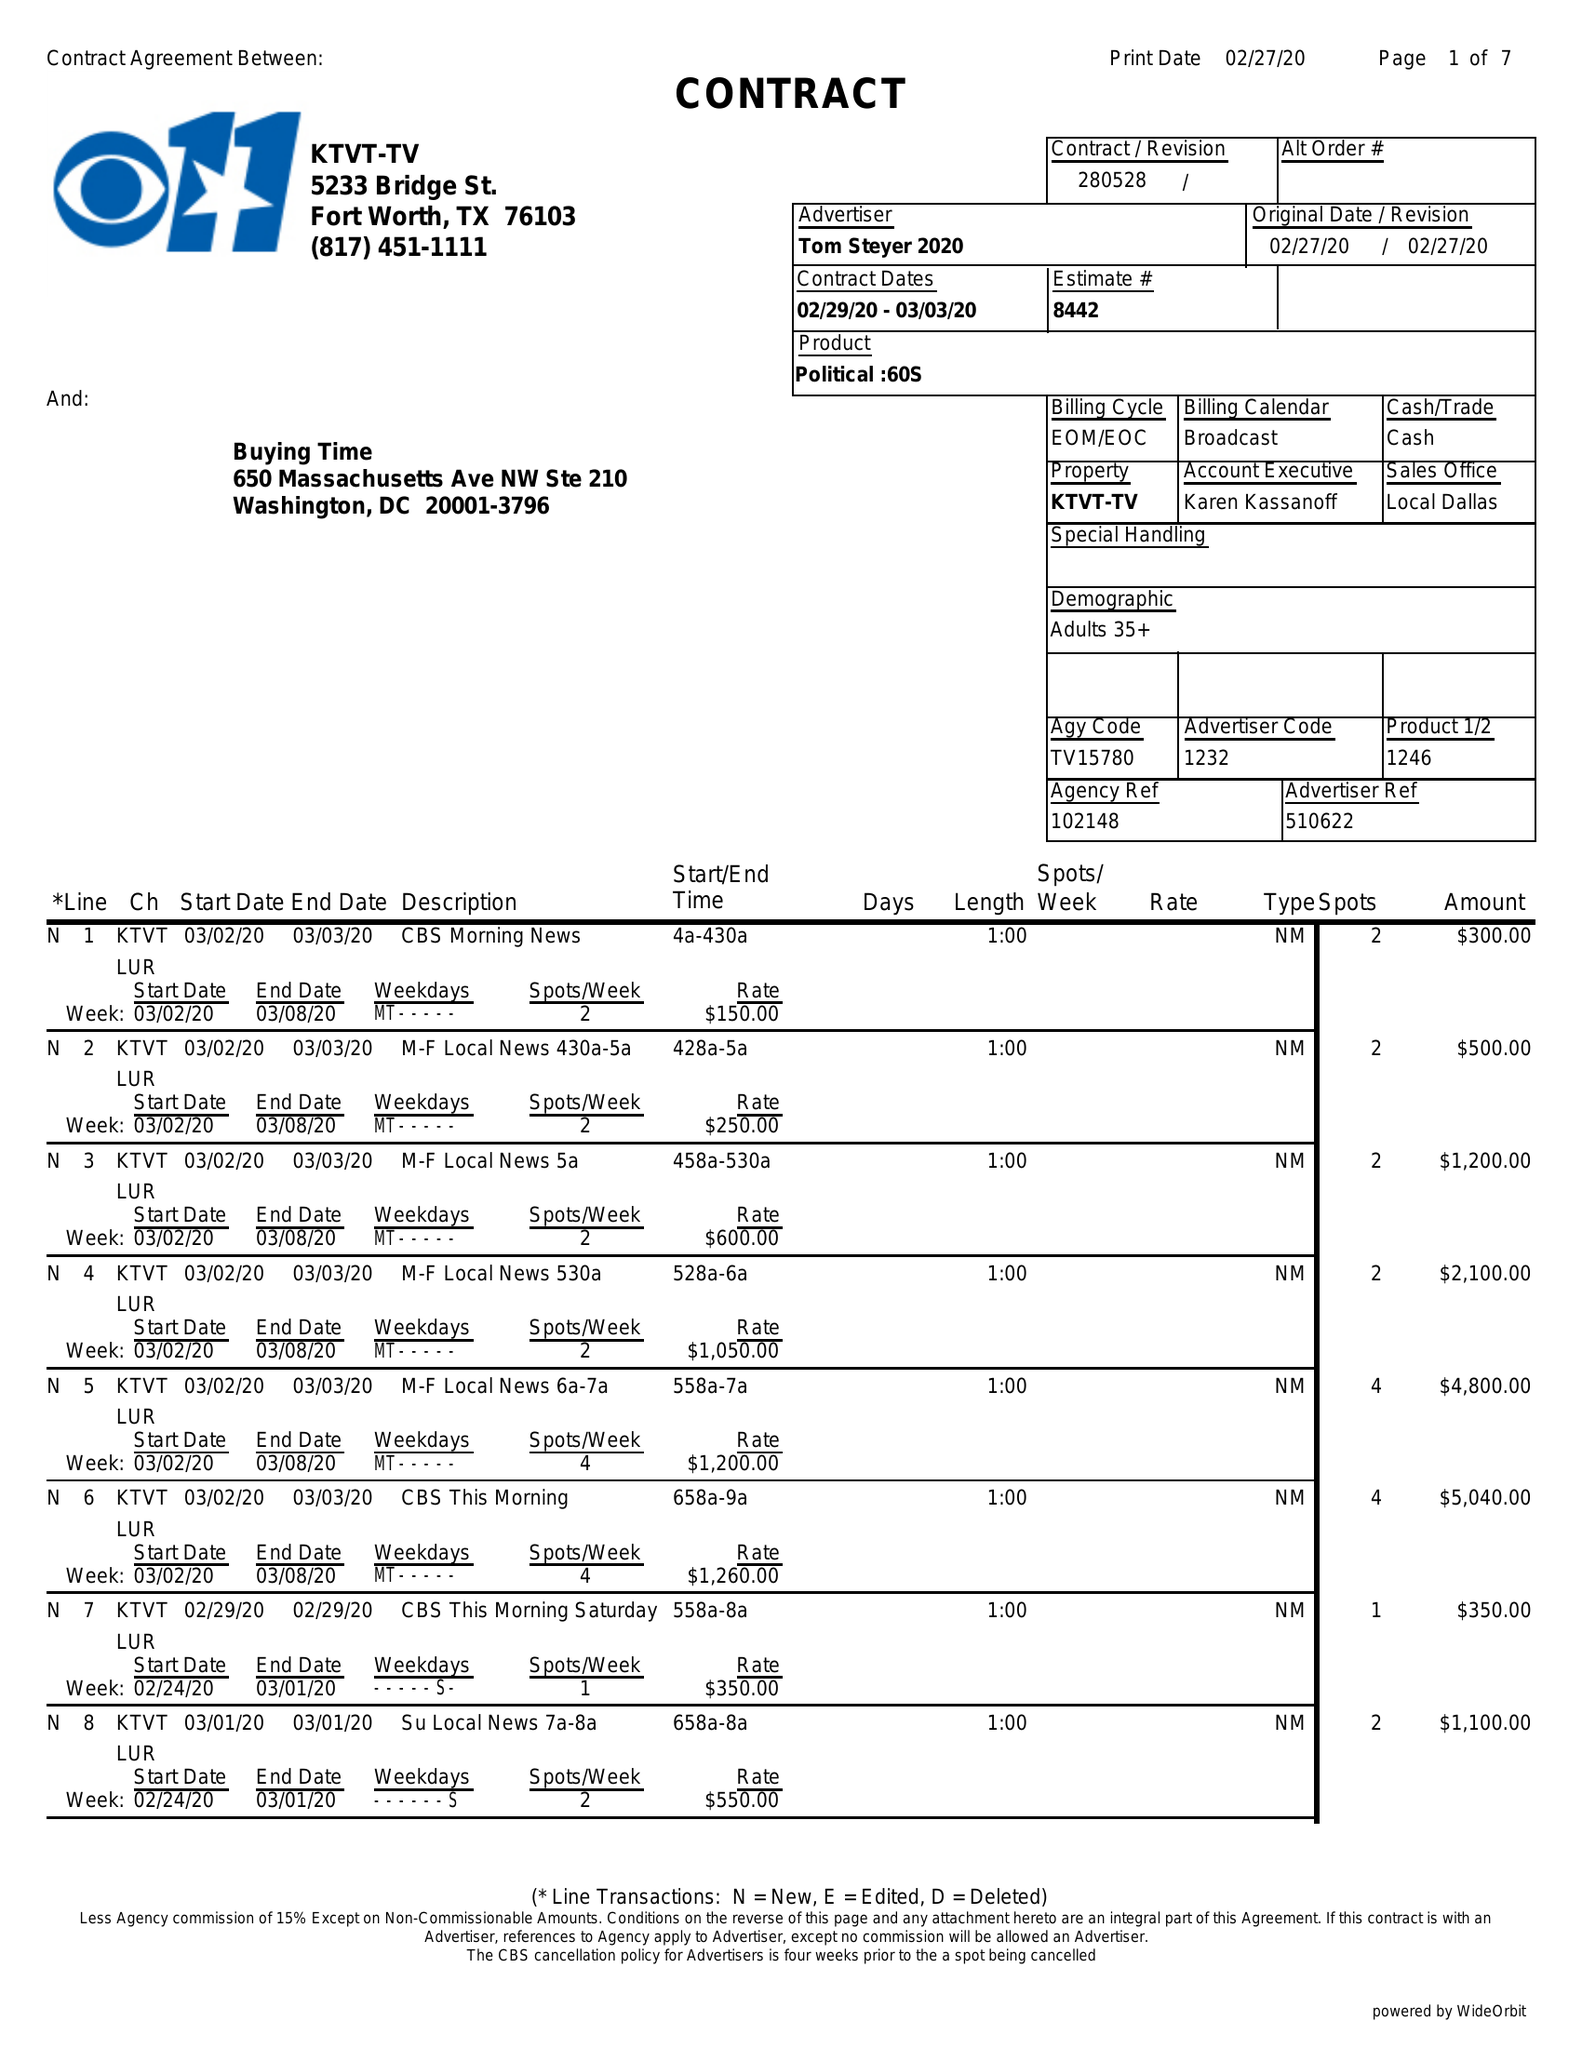What is the value for the contract_num?
Answer the question using a single word or phrase. 280528 